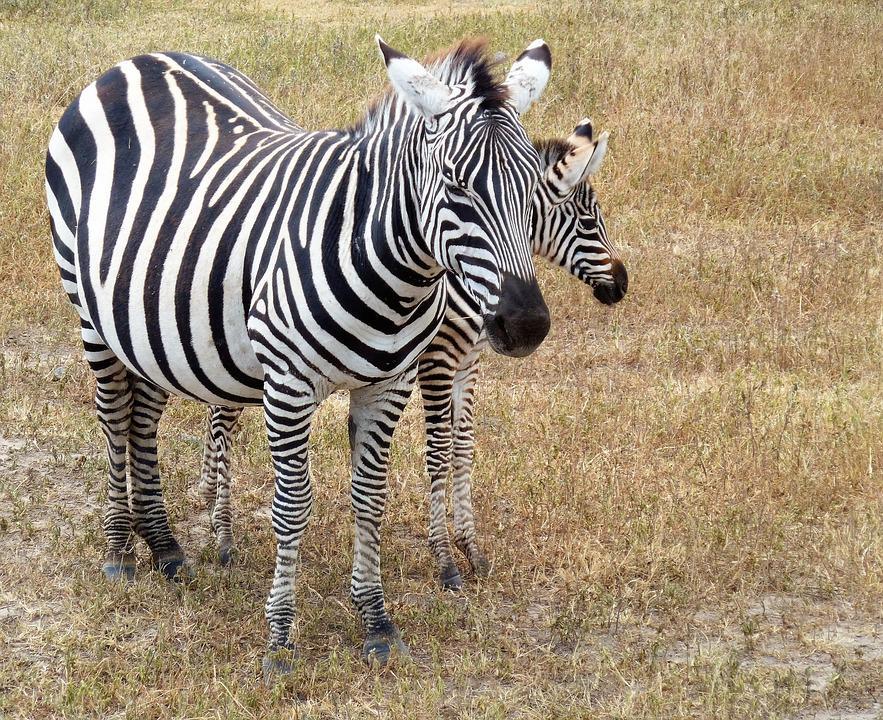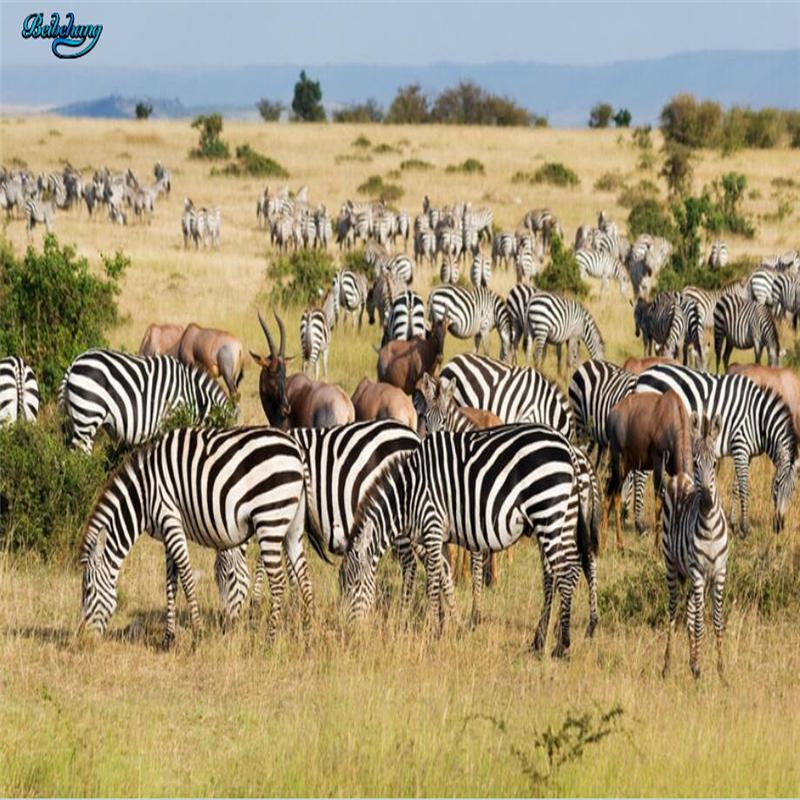The first image is the image on the left, the second image is the image on the right. Assess this claim about the two images: "There are two zebras in the left image.". Correct or not? Answer yes or no. Yes. The first image is the image on the left, the second image is the image on the right. Considering the images on both sides, is "One of the images shows exactly one zebra, while the other image shows exactly two which have a brown tint to their coloring." valid? Answer yes or no. No. 